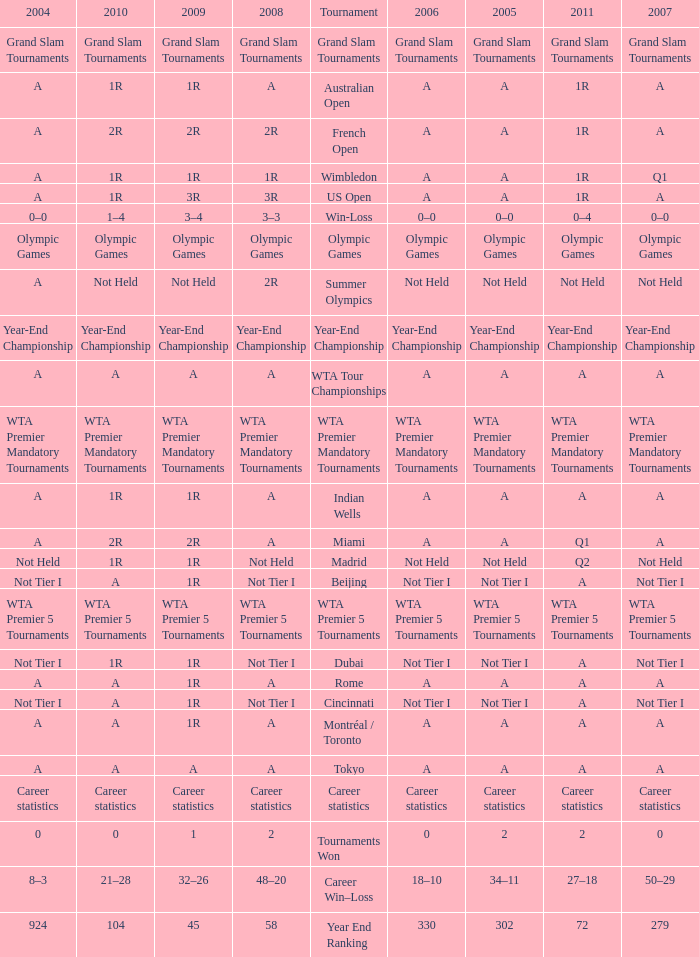What is 2010, when 2009 is "1"? 0.0. 